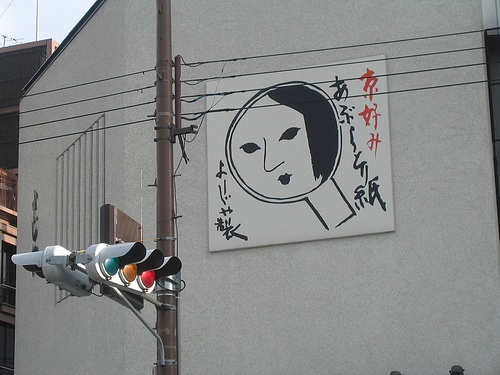Describe the objects in this image and their specific colors. I can see a traffic light in white, gray, black, and darkgray tones in this image. 